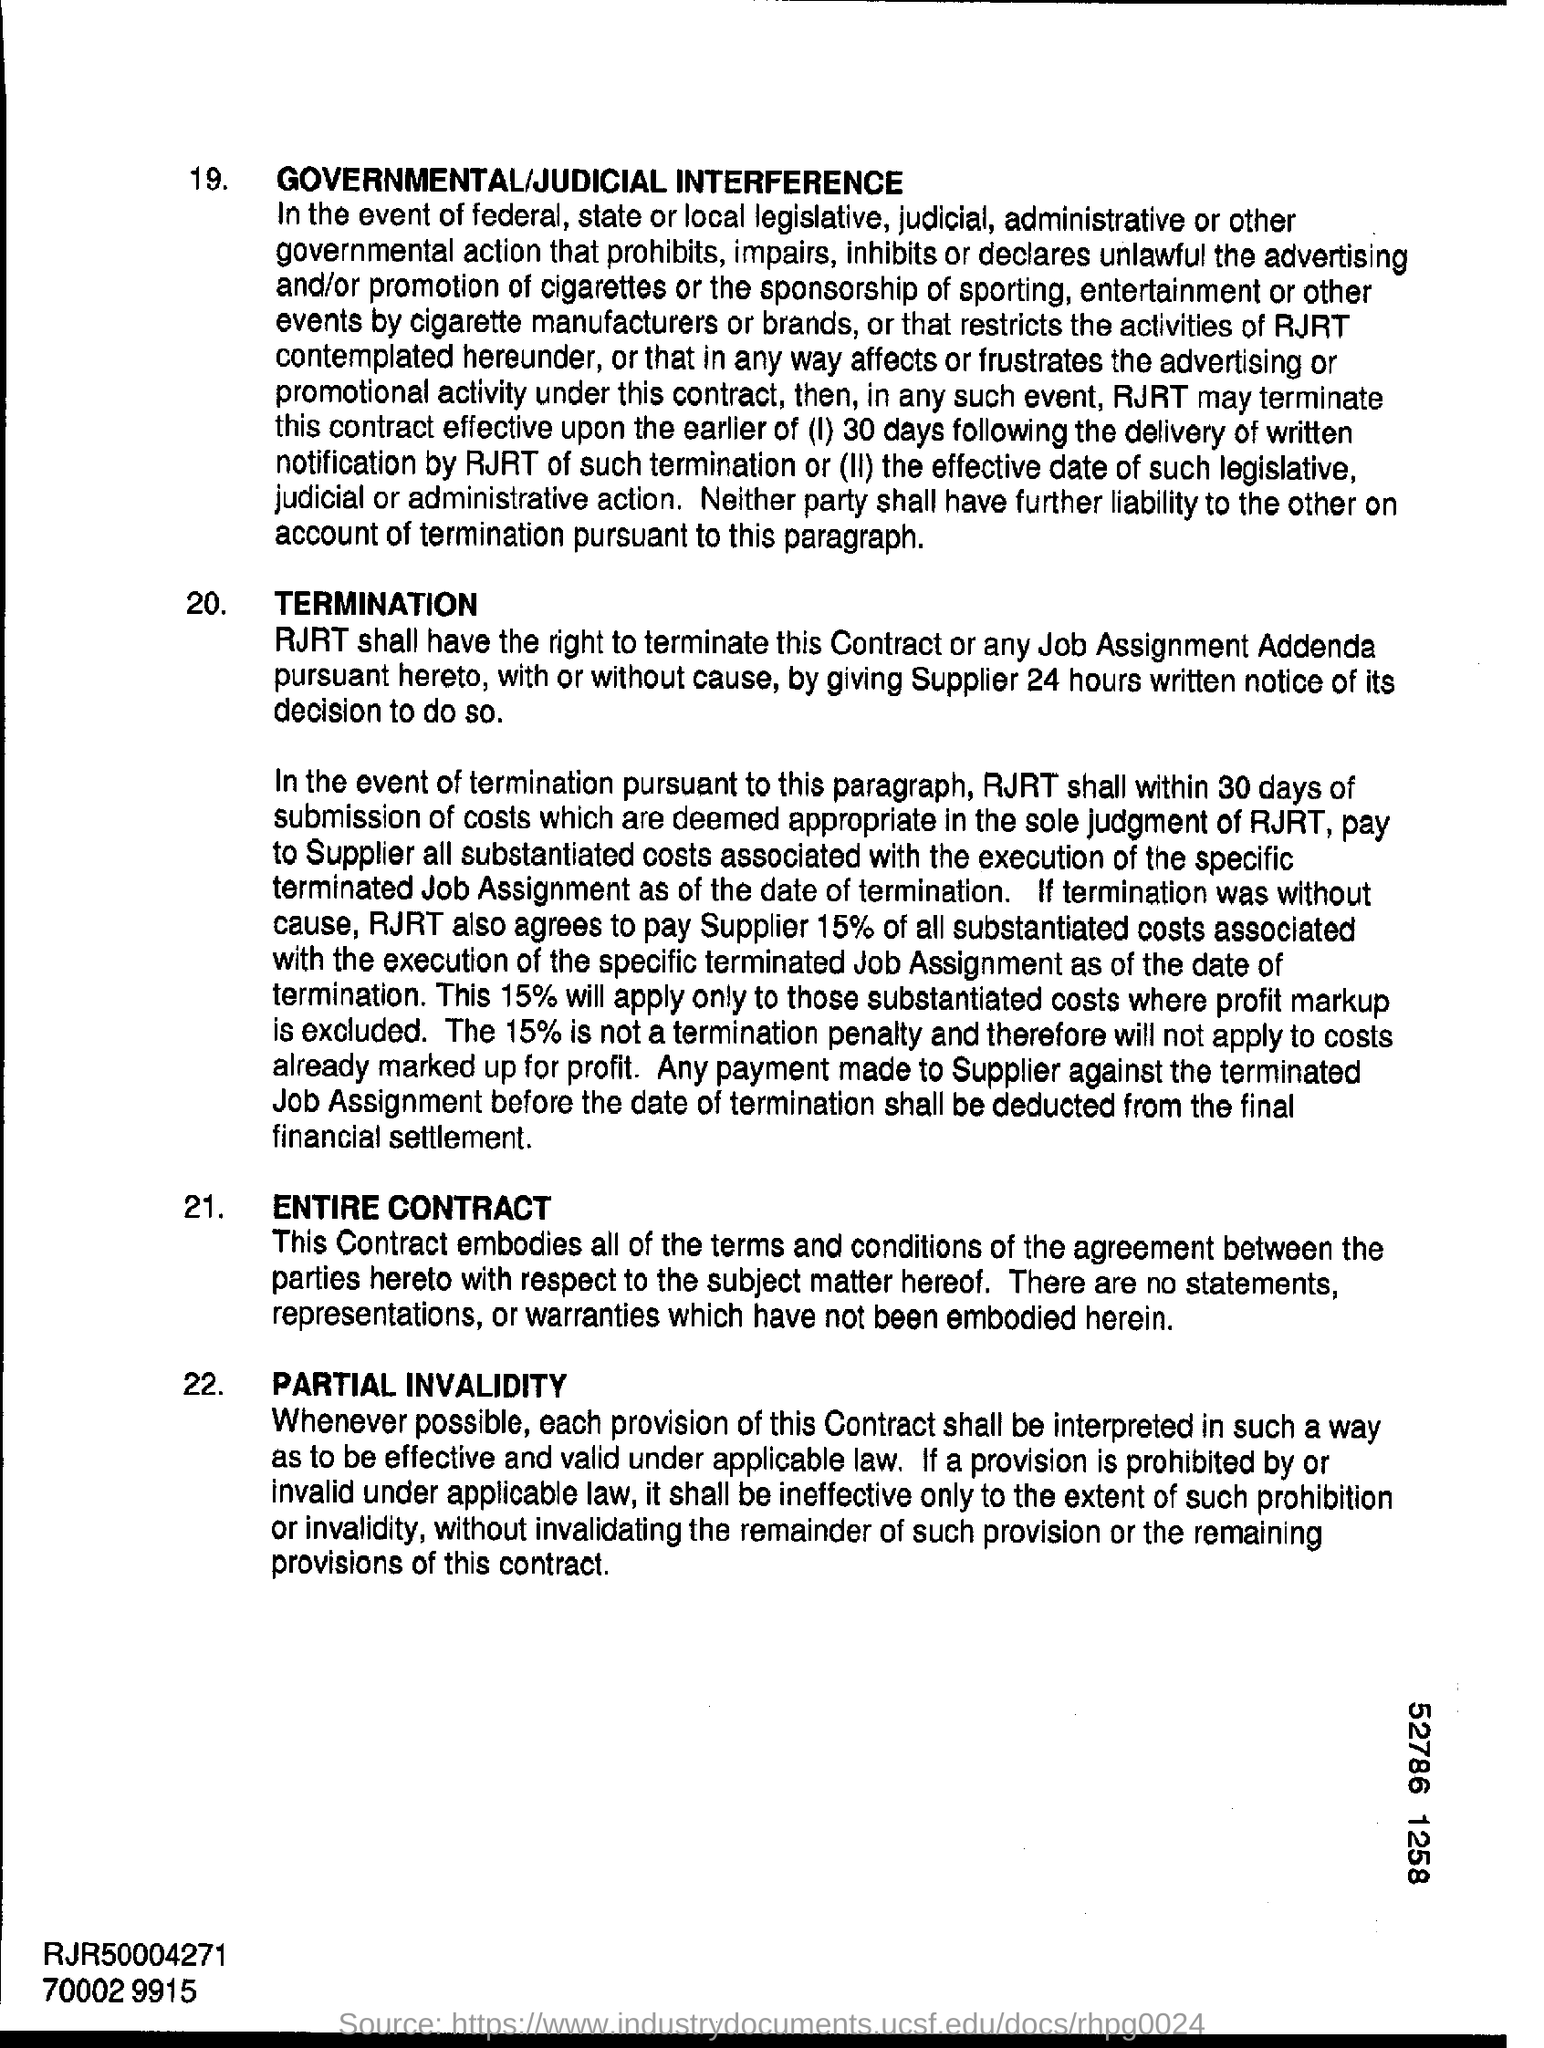Point out several critical features in this image. The digit displayed in the bottom right corner of the number 52786 is 1. 